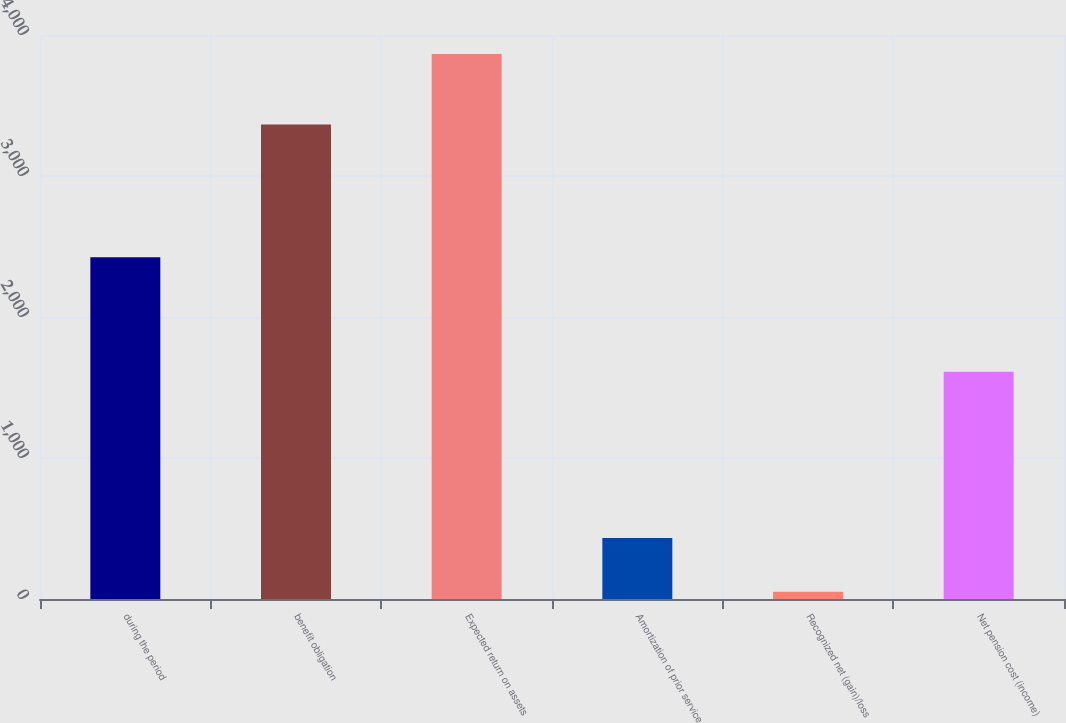Convert chart. <chart><loc_0><loc_0><loc_500><loc_500><bar_chart><fcel>during the period<fcel>benefit obligation<fcel>Expected return on assets<fcel>Amortization of prior service<fcel>Recognized net (gain)/loss<fcel>Net pension cost (income)<nl><fcel>2423<fcel>3366<fcel>3865<fcel>433.3<fcel>52<fcel>1612<nl></chart> 